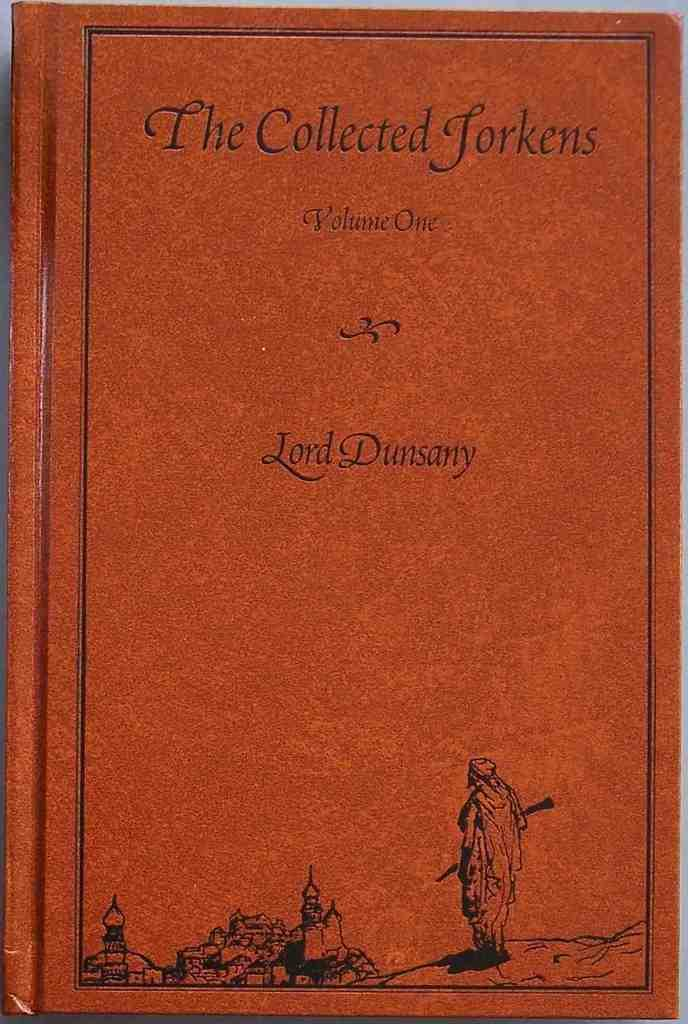<image>
Create a compact narrative representing the image presented. An orange book called The Collected Tockens by Lord Dunsany. 